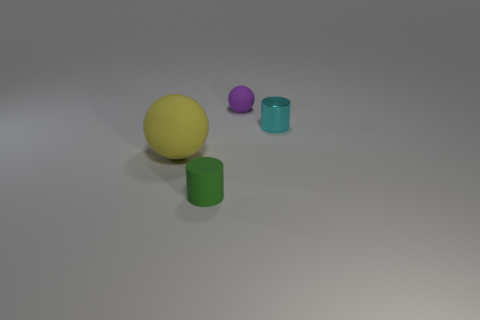Add 1 tiny purple metal blocks. How many objects exist? 5 Subtract 0 red balls. How many objects are left? 4 Subtract 1 balls. How many balls are left? 1 Subtract all purple cylinders. Subtract all yellow balls. How many cylinders are left? 2 Subtract all brown cylinders. How many yellow spheres are left? 1 Subtract all tiny cyan cylinders. Subtract all large yellow shiny blocks. How many objects are left? 3 Add 3 purple balls. How many purple balls are left? 4 Add 3 tiny gray rubber balls. How many tiny gray rubber balls exist? 3 Subtract all purple balls. How many balls are left? 1 